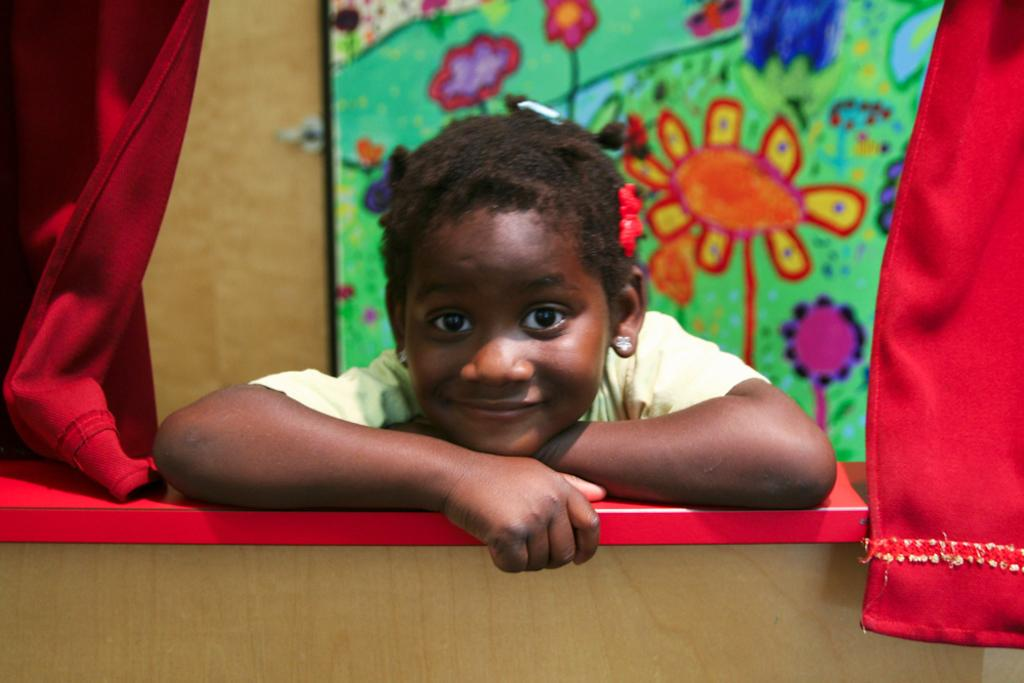Who or what is present in the image? There is a person in the image. What can be seen on the wall in the background? There is a colorful frame attached to the wall in the background. What type of window treatment is present in the image? There are red color curtains on both sides of the image. What type of honey is being sold at the station in the image? There is no station or honey present in the image; it features a person and a colorful frame on the wall. 